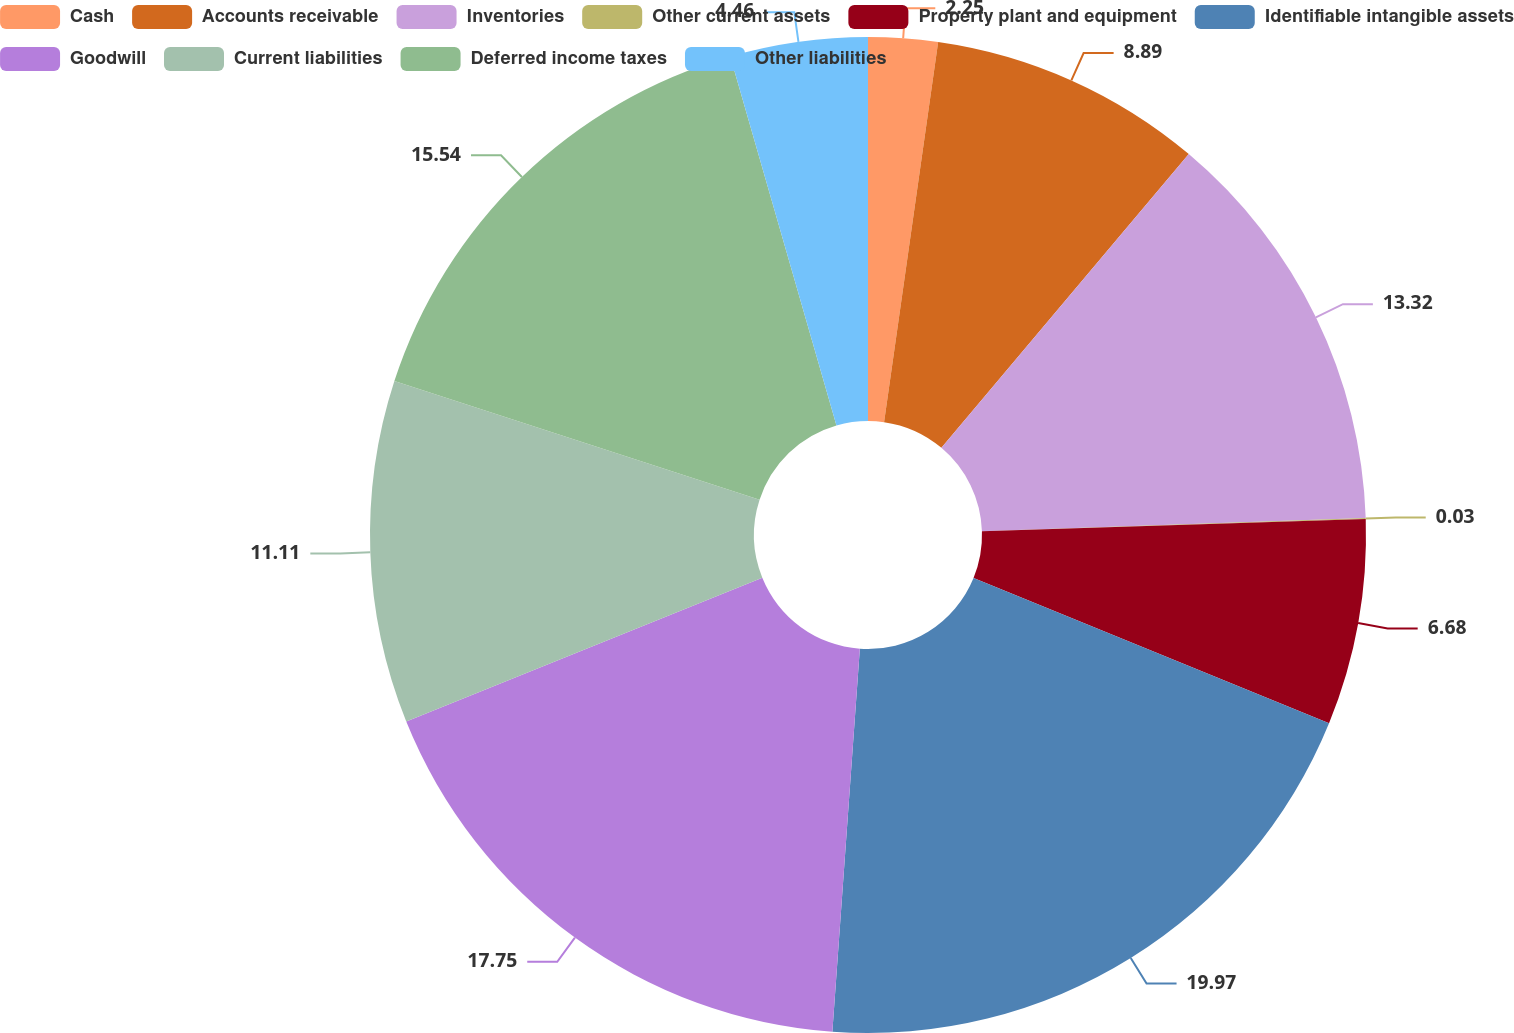Convert chart. <chart><loc_0><loc_0><loc_500><loc_500><pie_chart><fcel>Cash<fcel>Accounts receivable<fcel>Inventories<fcel>Other current assets<fcel>Property plant and equipment<fcel>Identifiable intangible assets<fcel>Goodwill<fcel>Current liabilities<fcel>Deferred income taxes<fcel>Other liabilities<nl><fcel>2.25%<fcel>8.89%<fcel>13.32%<fcel>0.03%<fcel>6.68%<fcel>19.97%<fcel>17.75%<fcel>11.11%<fcel>15.54%<fcel>4.46%<nl></chart> 